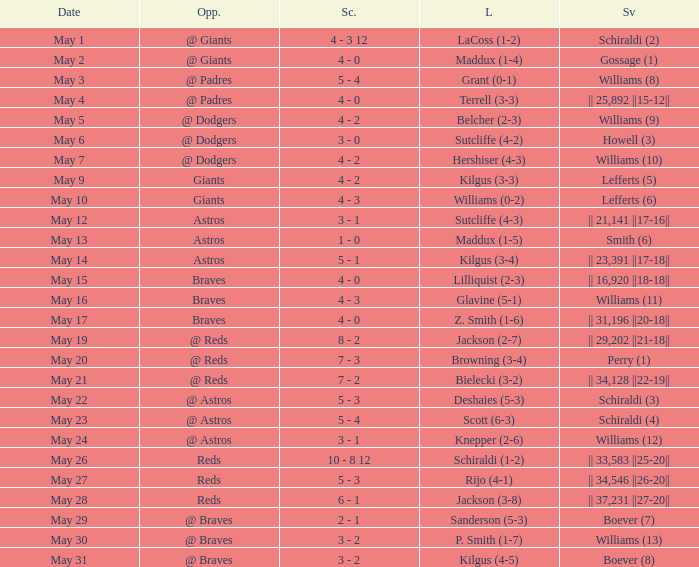Name the loss for may 1 LaCoss (1-2). 